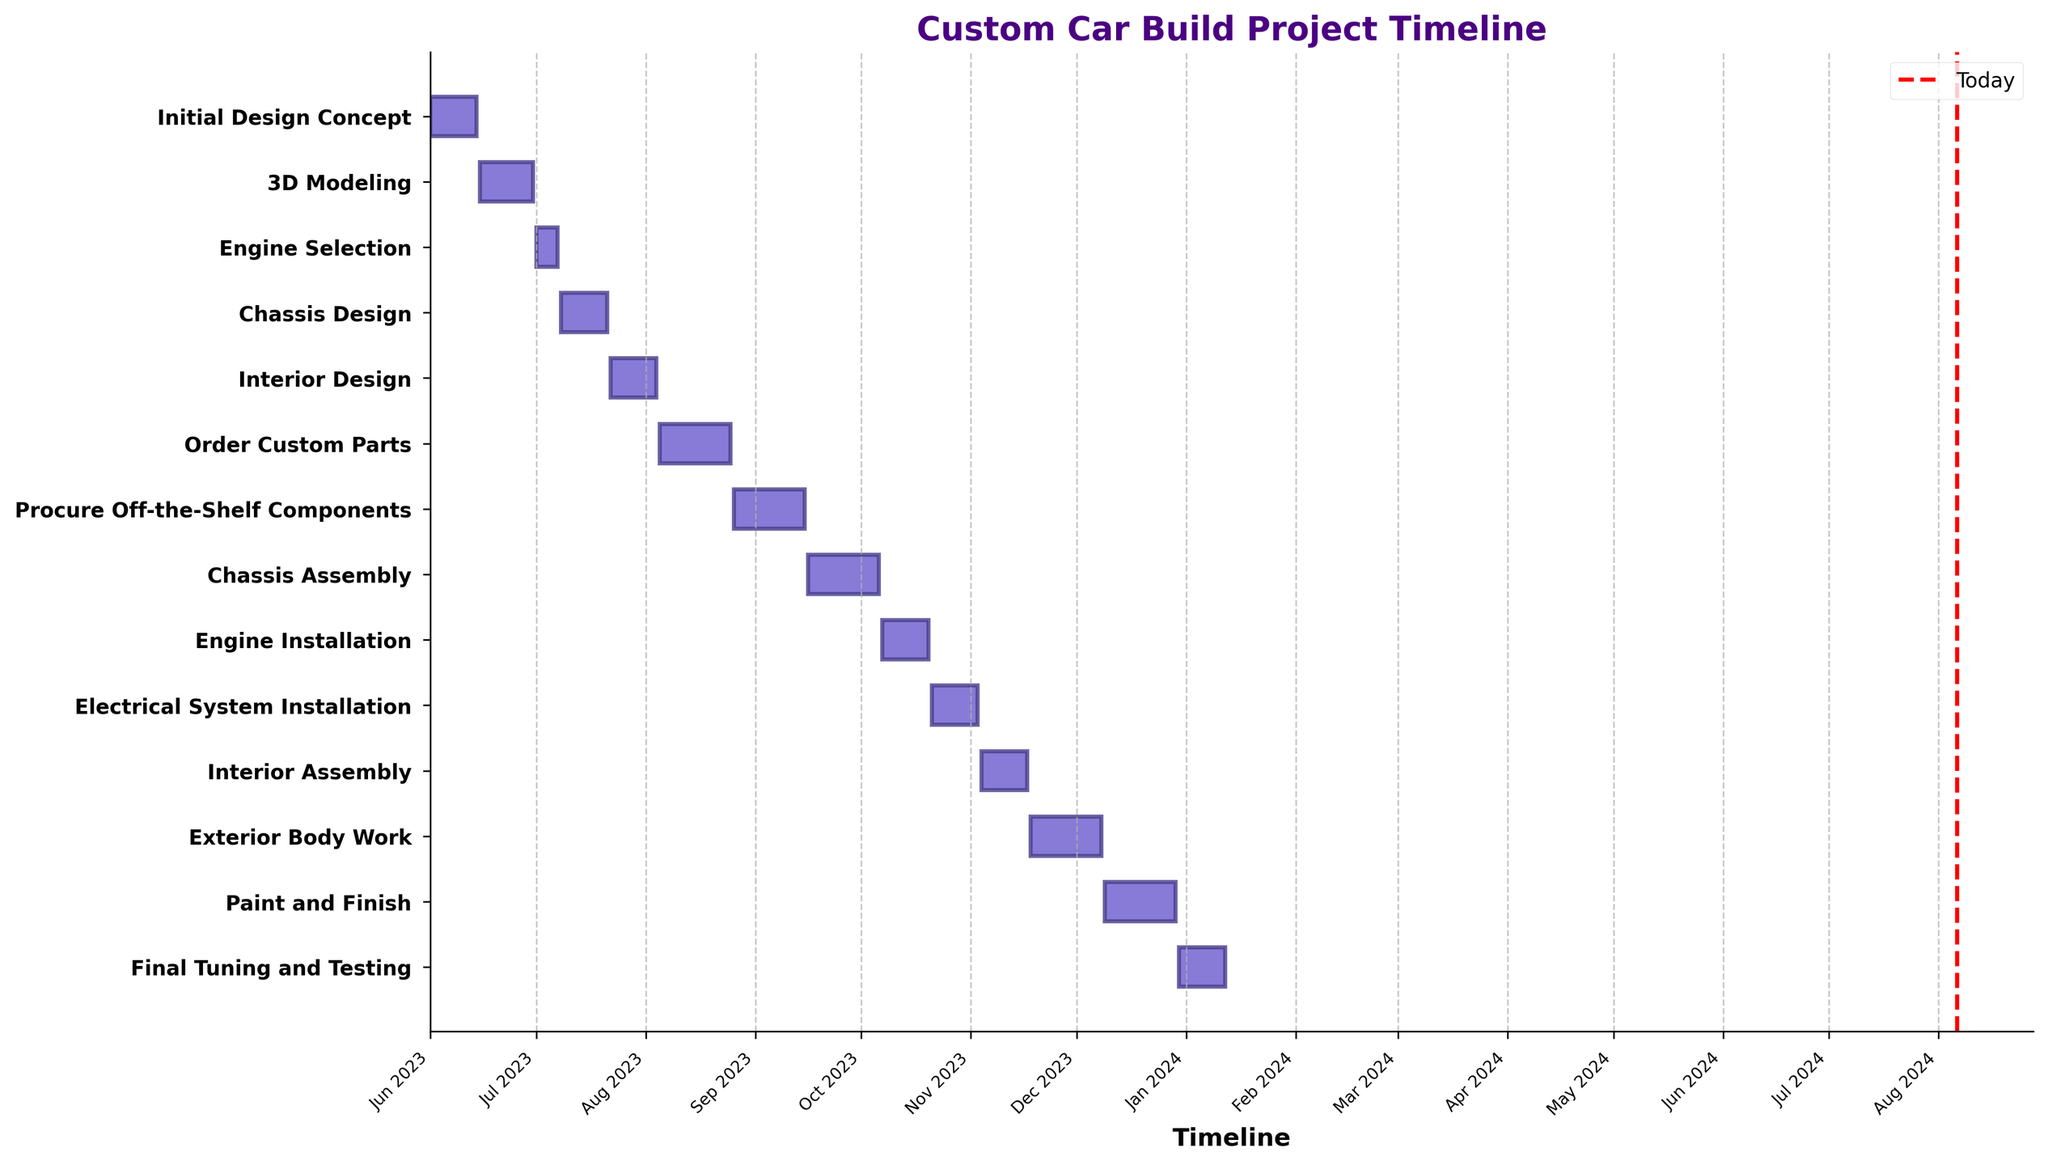What's the title of the Gantt chart? The title of a Gantt chart is usually displayed prominently at the top of the chart. In this case, it's easy to see it at the top of the figure.
Answer: Custom Car Build Project Timeline How many tasks are there in the project? By counting the number of horizontal bars or reading the y-axis labels, we can figure out the total number of tasks. There are 14 tasks listed.
Answer: 14 Which task has the longest duration? By comparing the lengths of the horizontal bars, we can determine that the task "Order Custom Parts" has the longest duration as its bar spans from August 5 to August 25, totaling to 21 days.
Answer: Order Custom Parts What is the duration of the "Interior Assembly" task? The "Interior Assembly" task's horizontal bar spans from November 4 to November 17. Calculating the difference between these dates gives us the duration.
Answer: 14 days Which task starts first and which task ends last? The first task that starts is "Initial Design Concept" on June 1, 2023, and the last task that ends is "Final Tuning and Testing," which ends on January 12, 2024.
Answer: Initial Design Concept, Final Tuning and Testing How long is the interval between the 'Chassis Design' and 'Order Custom Parts'? 'Chassis Design' ends on July 21, and 'Order Custom Parts' starts on August 5. The interval between the end of one task and the start of the next task is 15 days.
Answer: 15 days What's the difference in start dates between "Engine Selection" and "Paint and Finish"? "Engine Selection" starts on July 1, and "Paint and Finish" starts on December 9. Calculating the difference between these dates gives us 161 days.
Answer: 161 days Which task ends right before "Interior Design"? To find this, we look at the task that ends just before July 22. "Chassis Design," which ends on July 21, fits this criterion.
Answer: Chassis Design Which month has the highest number of tasks starting? By observing the start dates, we find that August has the highest number of tasks starting (August 5, 26).
Answer: August What tasks are scheduled to overlap with "Engine Installation"? "Engine Installation" spans from October 7 to October 20. By looking for tasks that intersect with this range, we find "Chassis Assembly" which overlaps from September 16 to October 6 and "Electrical System Installation" from October 21 to November 3.
Answer: None 